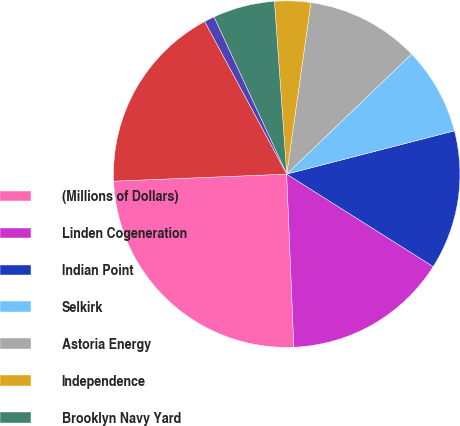Convert chart. <chart><loc_0><loc_0><loc_500><loc_500><pie_chart><fcel>(Millions of Dollars)<fcel>Linden Cogeneration<fcel>Indian Point<fcel>Selkirk<fcel>Astoria Energy<fcel>Independence<fcel>Brooklyn Navy Yard<fcel>Indeck Corinth<fcel>Total<nl><fcel>25.01%<fcel>15.39%<fcel>12.98%<fcel>8.17%<fcel>10.58%<fcel>3.36%<fcel>5.77%<fcel>0.96%<fcel>17.79%<nl></chart> 